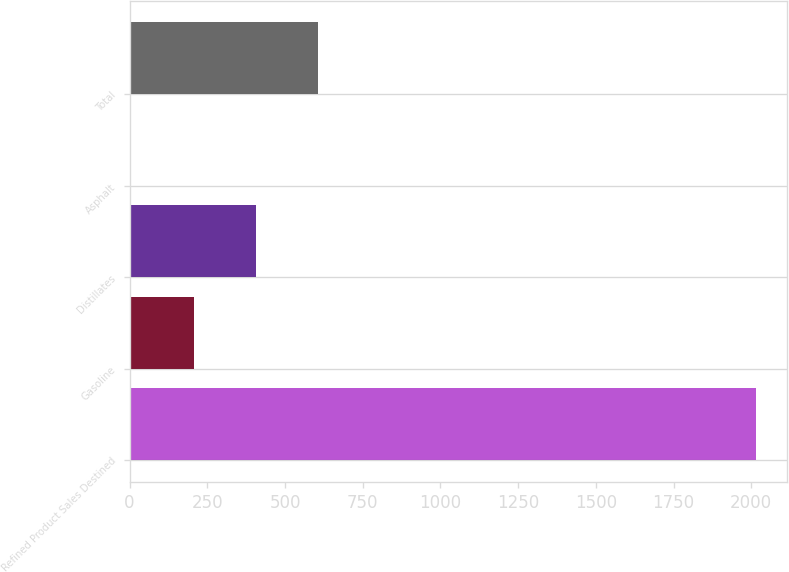Convert chart. <chart><loc_0><loc_0><loc_500><loc_500><bar_chart><fcel>Refined Product Sales Destined<fcel>Gasoline<fcel>Distillates<fcel>Asphalt<fcel>Total<nl><fcel>2014<fcel>205.9<fcel>406.8<fcel>5<fcel>607.7<nl></chart> 